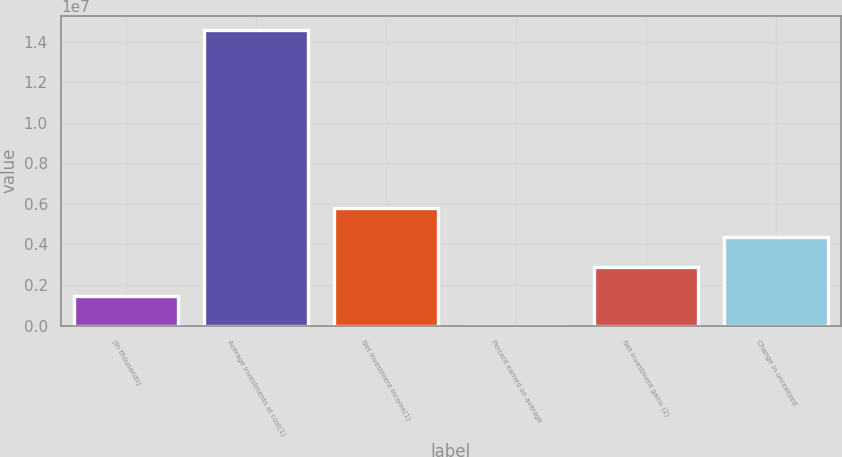<chart> <loc_0><loc_0><loc_500><loc_500><bar_chart><fcel>(In thousands)<fcel>Average investments at cost(1)<fcel>Net investment income(1)<fcel>Percent earned on average<fcel>Net investment gains (2)<fcel>Change in unrealized<nl><fcel>1.45454e+06<fcel>1.45454e+07<fcel>5.81815e+06<fcel>4<fcel>2.90908e+06<fcel>4.36361e+06<nl></chart> 